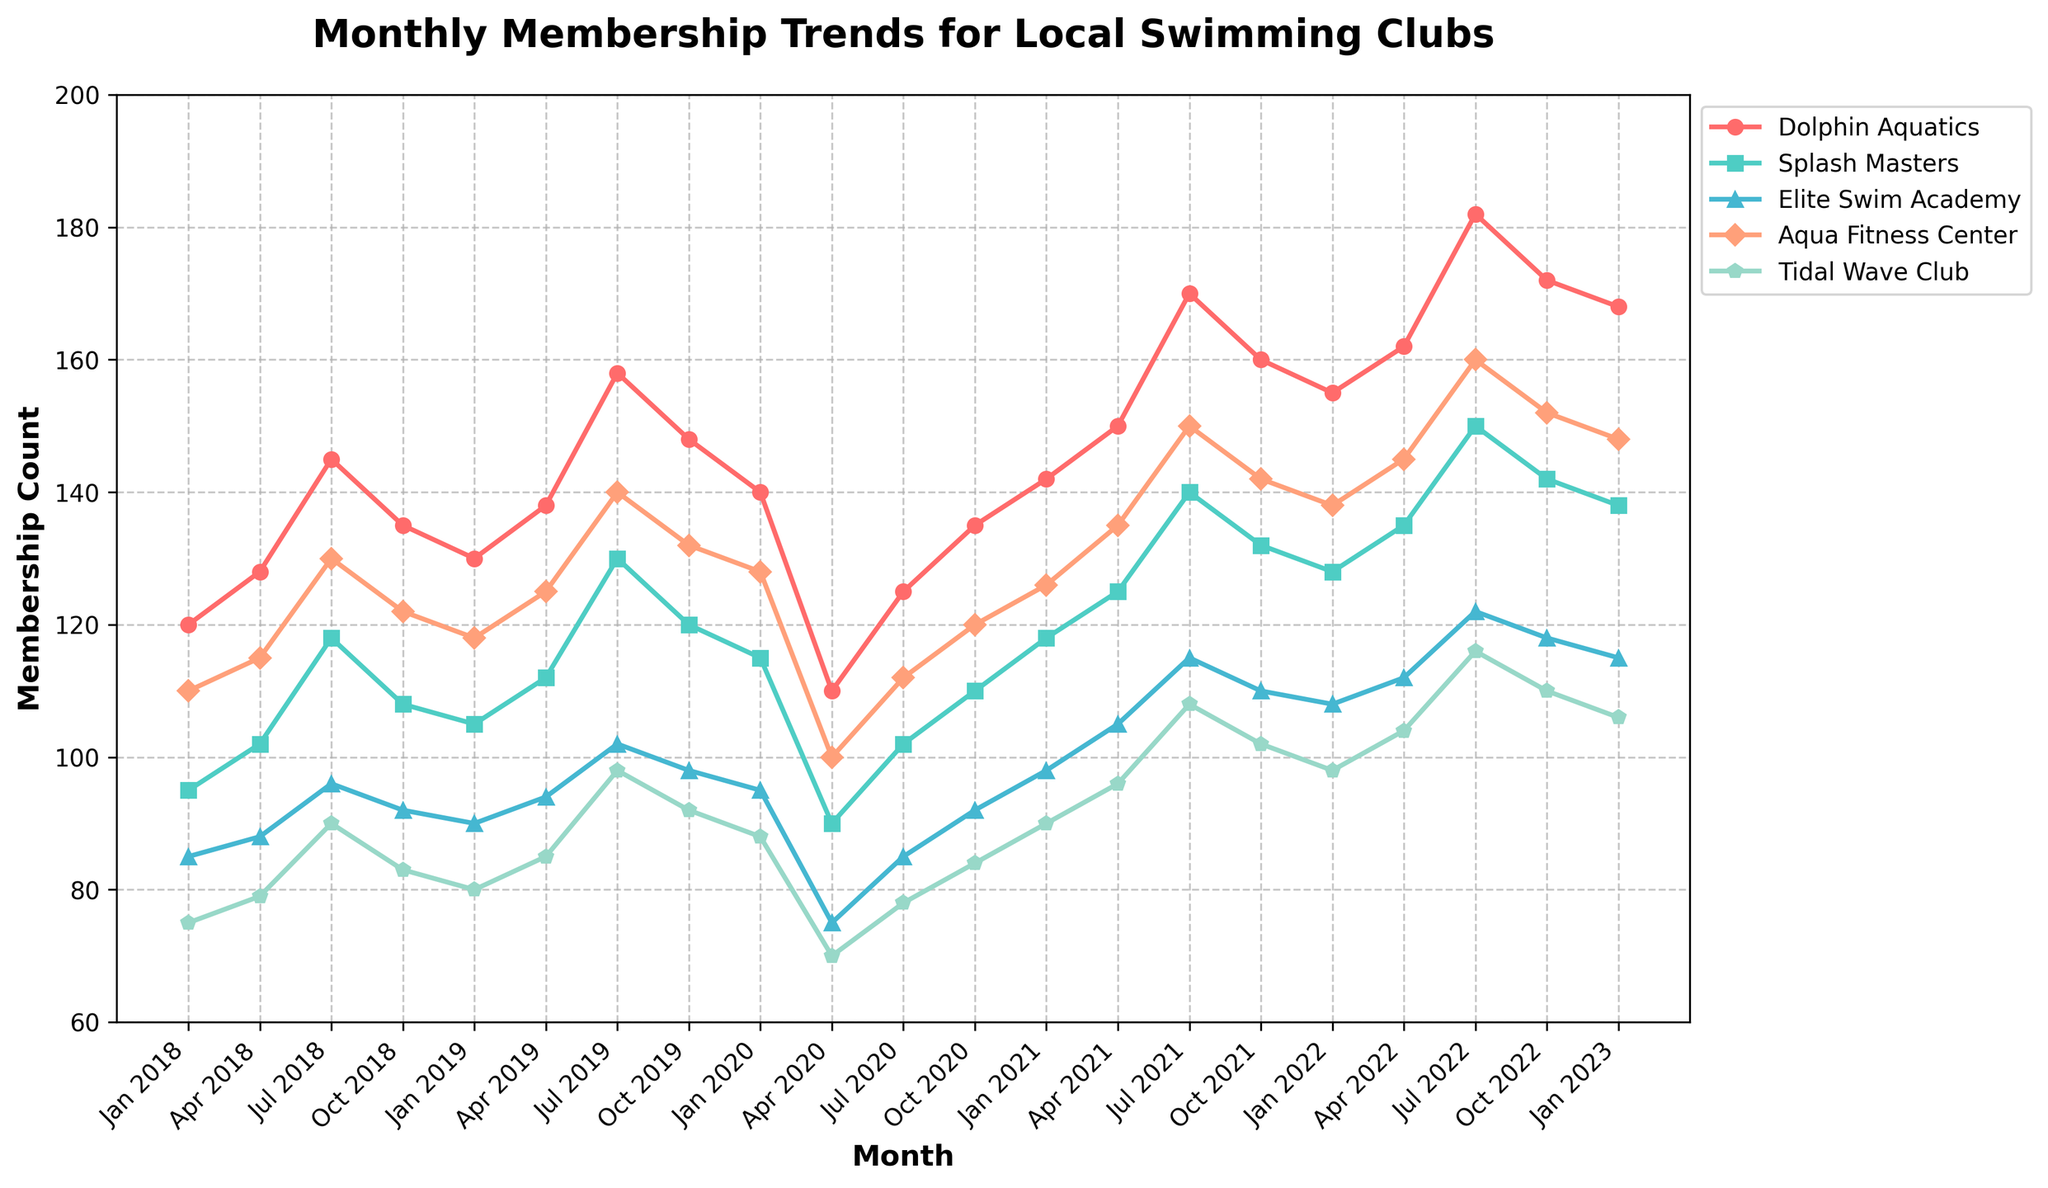What's the trend for Dolphin Aquatics from Jan 2020 to Jan 2022? Observe the data points for Dolphin Aquatics at Jan 2020, Jan 2021, and Jan 2022. Membership counts are 140, 142, and 155 respectively. The trend shows a gradual increase.
Answer: Gradual increase Which club had the steepest membership drop in Apr 2020? Compare the membership counts across all clubs in Apr 2020 with the previous quarter (Jan 2020). The steepest drop is for Dolphin Aquatics, from 140 to 110.
Answer: Dolphin Aquatics Between which two periods did Aqua Fitness Center see the largest growth in memberships? Examine the differences in membership count for Aqua Fitness Center across all periods. The largest growth is between Jul 2021 (150) and Oct 2021 (142).
Answer: Apr 2021 to Jul 2021 Which club has the most consistent membership trend with fewer fluctuations? Observe the line smoothness for each club. Aqua Fitness Center has the most consistent and smooth trend over the period.
Answer: Aqua Fitness Center How did Tidal Wave Club's membership change from Jul 2018 to Jul 2022? Compare the membership numbers of Tidal Wave Club in Jul 2018 (90) and Jul 2022 (116). The membership increased from 90 to 116.
Answer: Increase Comparing Jan 2020 and Jan 2023, what is the percentage increase in membership for Elite Swim Academy? Calculate the increase: Jan 2020 is 95, Jan 2023 is 115. Increase = 115 - 95 = 20. Percentage increase = (20 / 95) * 100.
Answer: 21.05% Which month and year did Splash Masters have the highest membership count? Locate the highest point on the Splash Masters line. It is in Jul 2022 with a membership count of 150.
Answer: Jul 2022 Which club had the highest membership in Jul 2022? Identify the highest point in Jul 2022 across all clubs. Dolphin Aquatics had the highest membership with 182.
Answer: Dolphin Aquatics How many months did Elite Swim Academy surpass 100 members? Count the number of data points above 100 on the Elite Swim Academy line. The months are Apr 2021, Jul 2021, Oct 2021, Apr 2022, Jul 2022, Oct 2022, Jan 2023 which totals to 7.
Answer: 7 